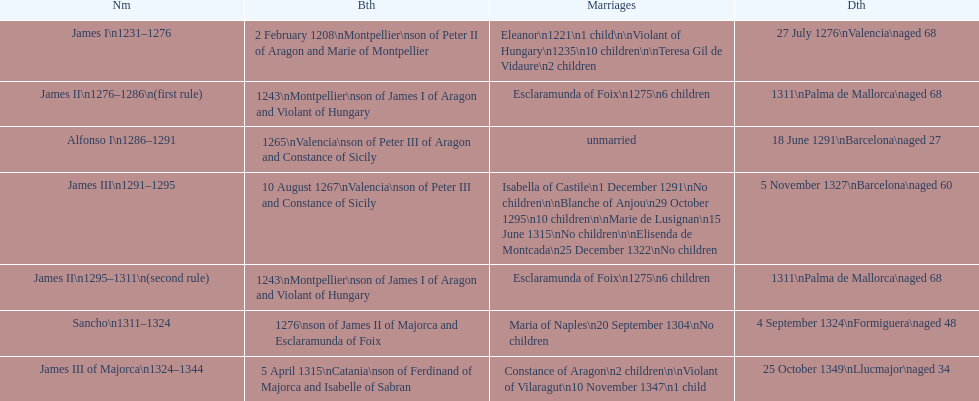How long was james ii in power, including his second rule? 26 years. 